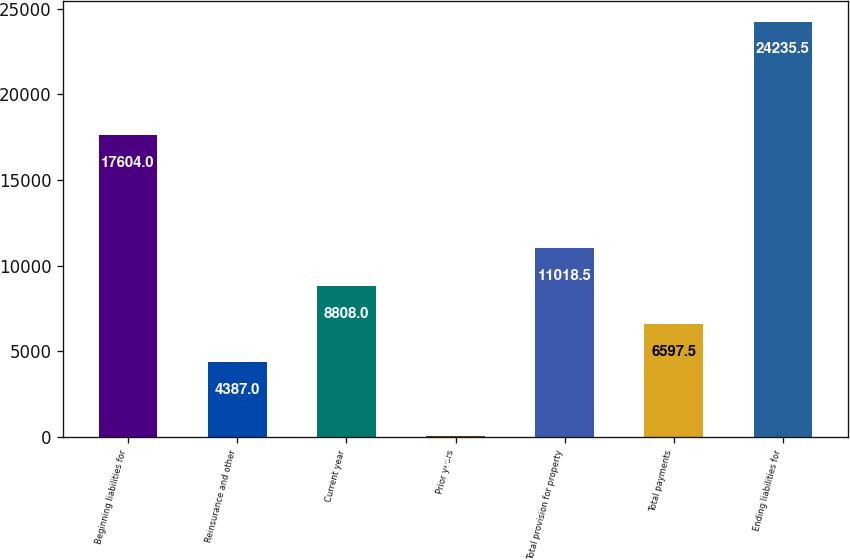Convert chart to OTSL. <chart><loc_0><loc_0><loc_500><loc_500><bar_chart><fcel>Beginning liabilities for<fcel>Reinsurance and other<fcel>Current year<fcel>Prior years<fcel>Total provision for property<fcel>Total payments<fcel>Ending liabilities for<nl><fcel>17604<fcel>4387<fcel>8808<fcel>48<fcel>11018.5<fcel>6597.5<fcel>24235.5<nl></chart> 